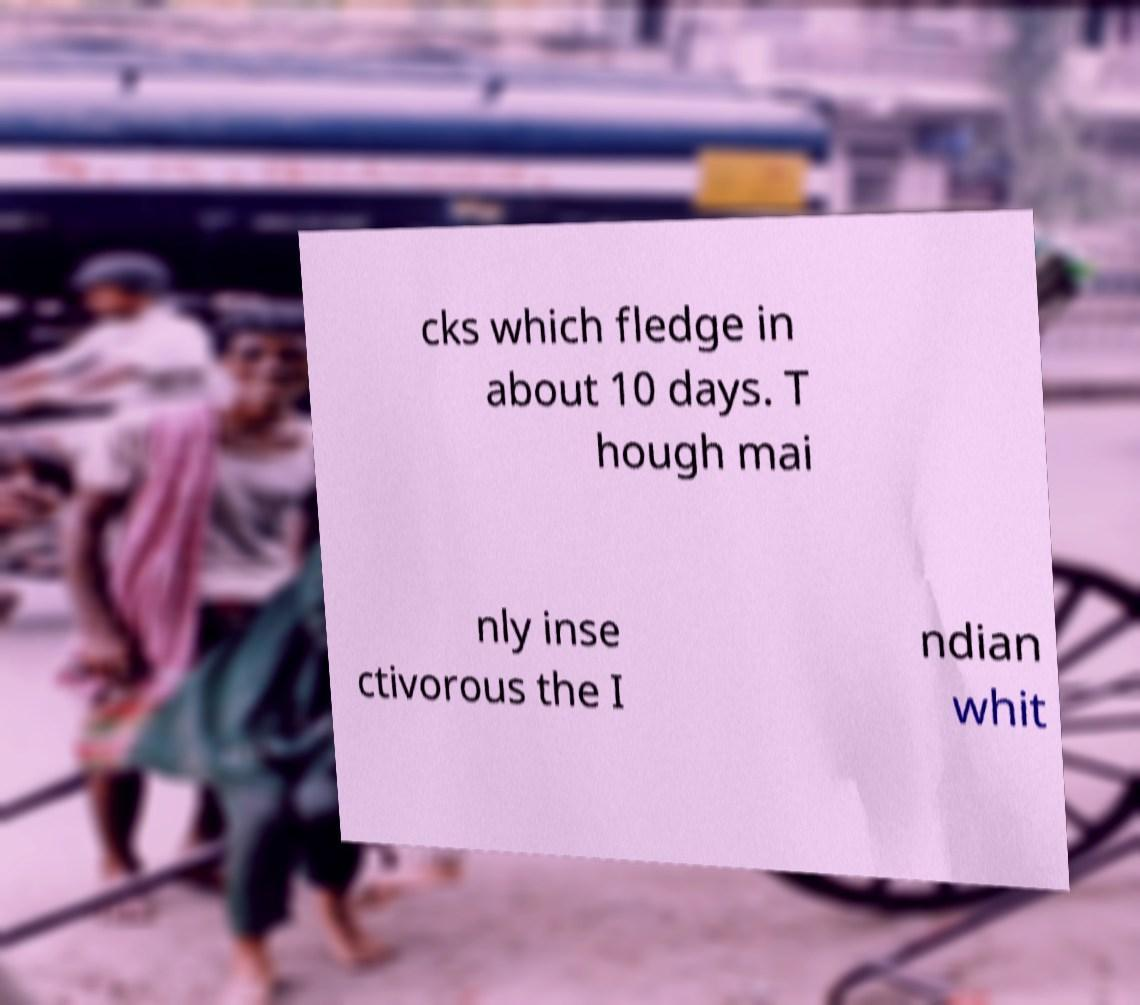For documentation purposes, I need the text within this image transcribed. Could you provide that? cks which fledge in about 10 days. T hough mai nly inse ctivorous the I ndian whit 